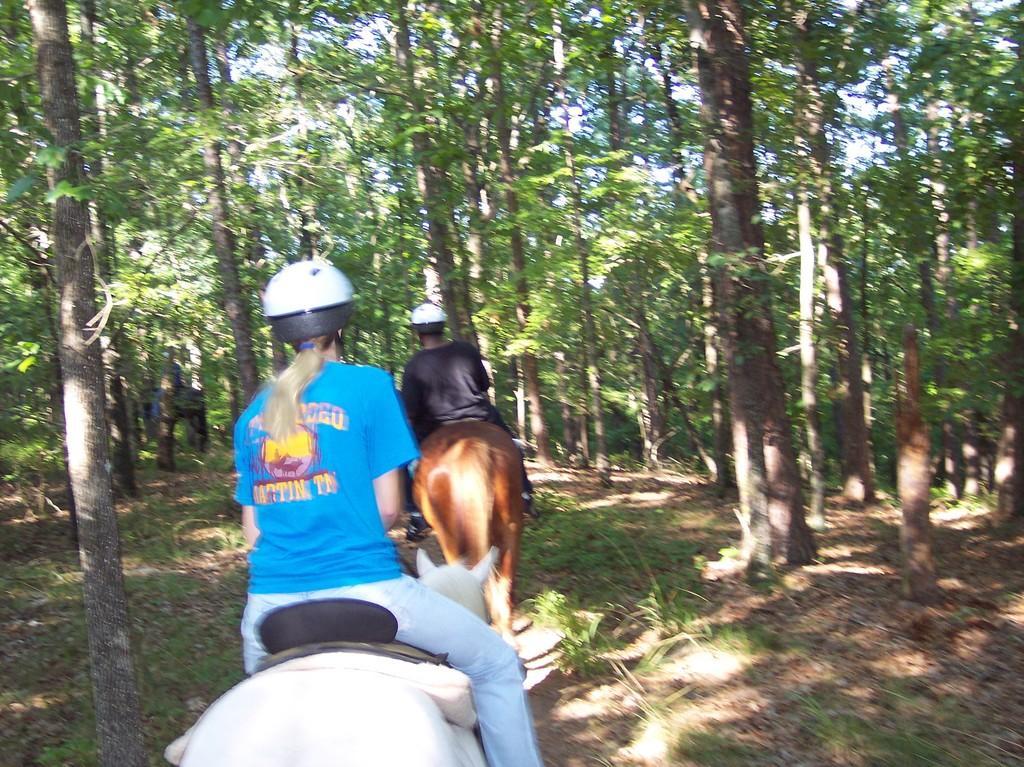Can you describe this image briefly? In this image we can see a blue t shirt lady and black t shirt men are riding on the horse. We can see many trees in the background. 